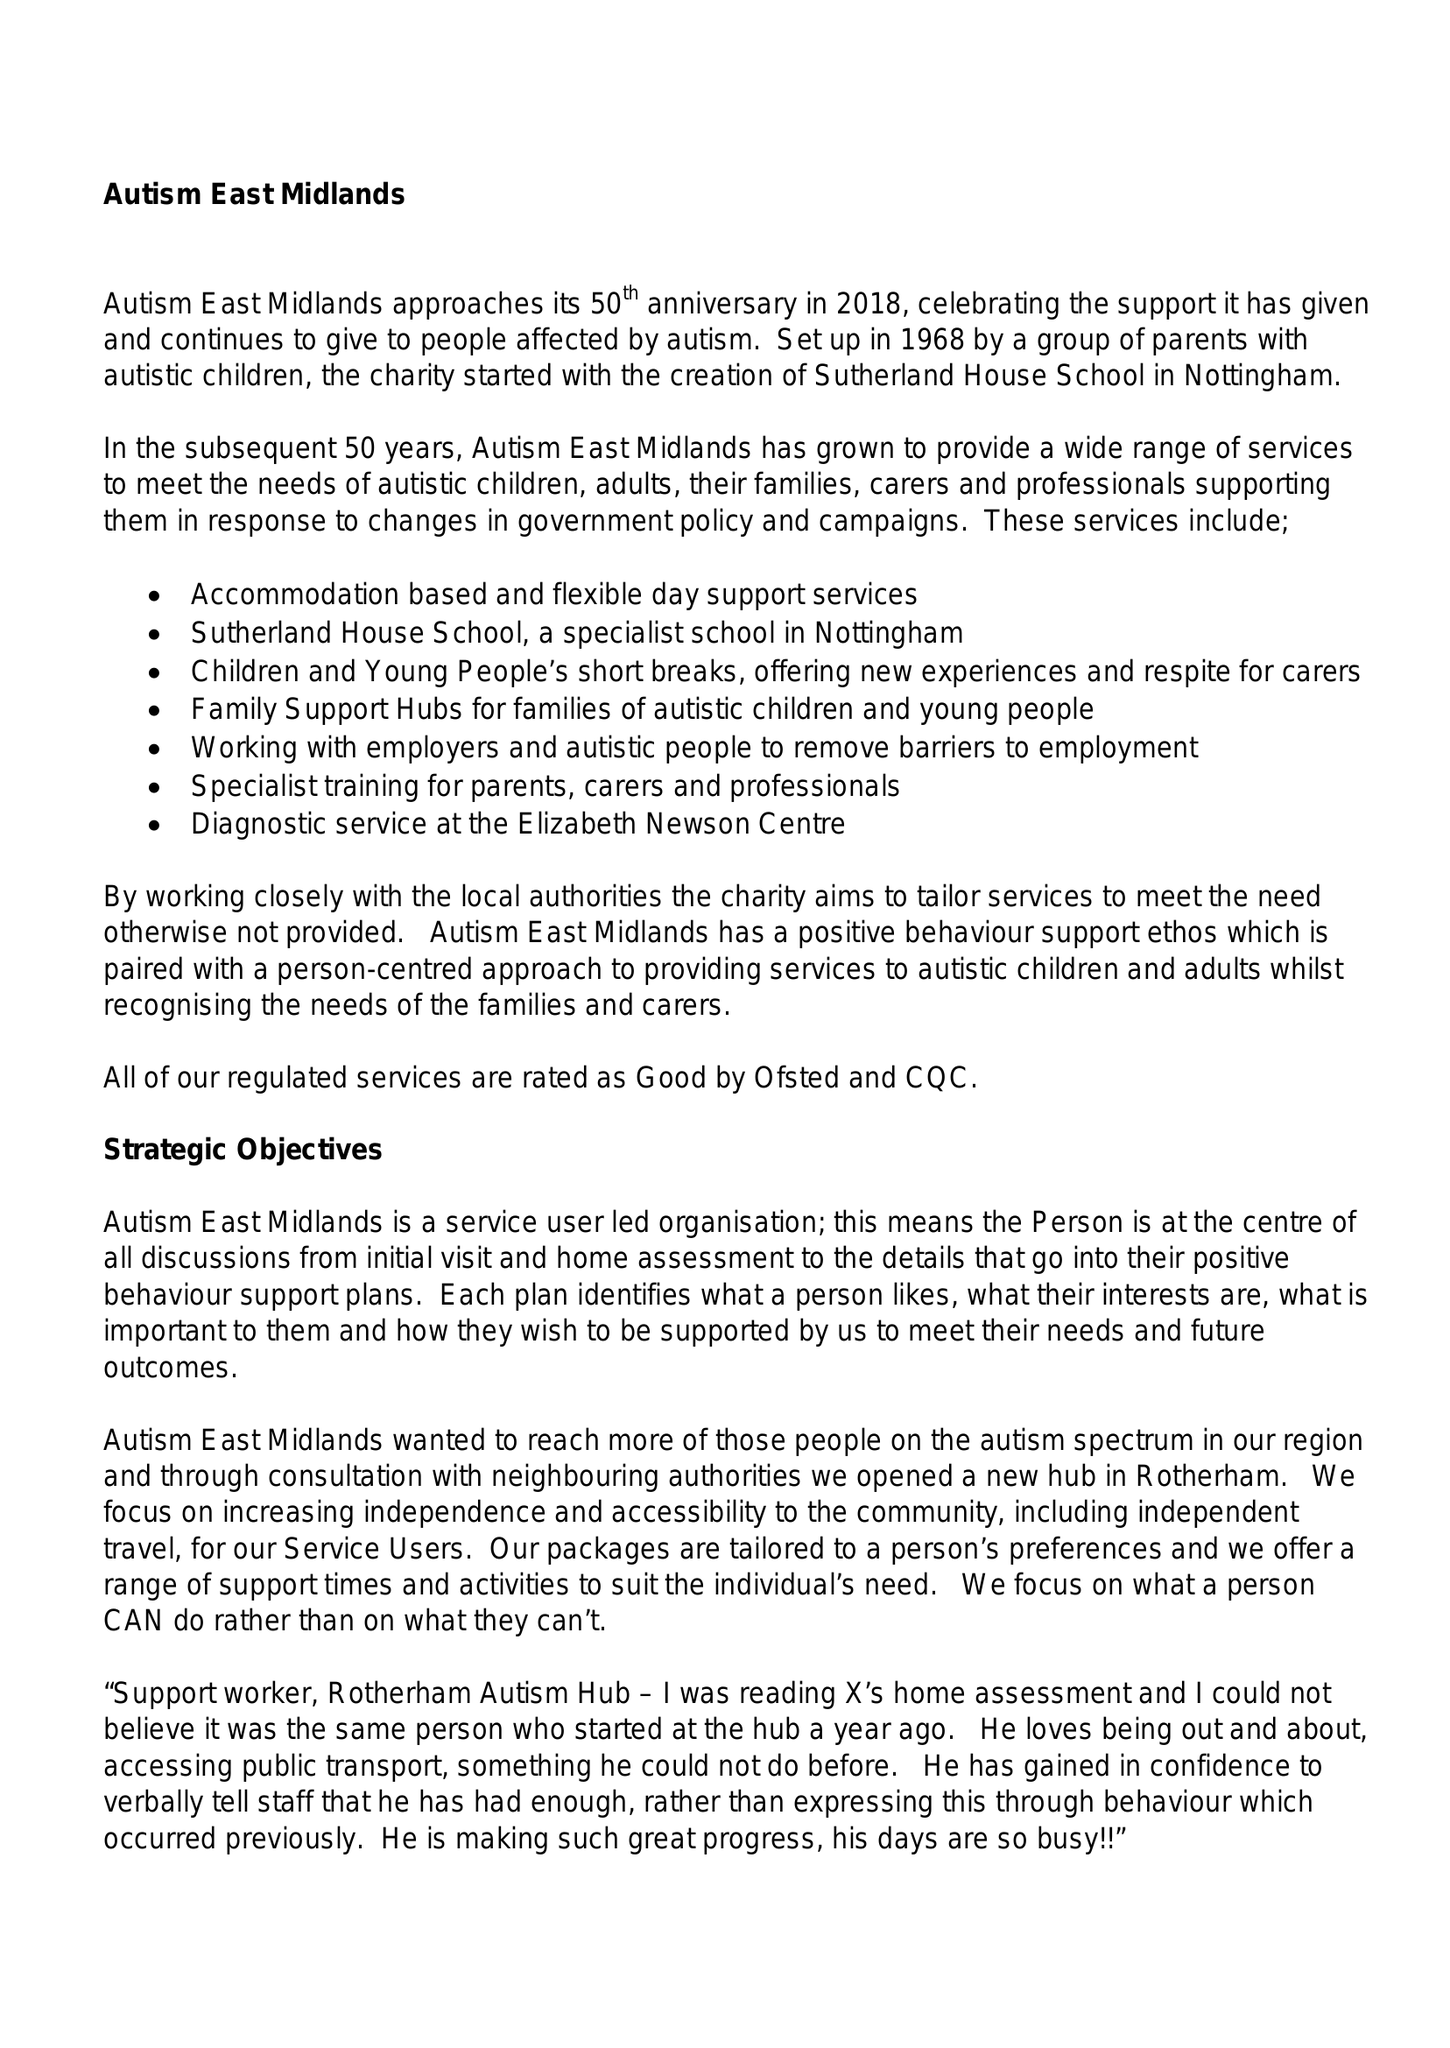What is the value for the spending_annually_in_british_pounds?
Answer the question using a single word or phrase. 11177793.00 